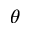<formula> <loc_0><loc_0><loc_500><loc_500>\theta</formula> 